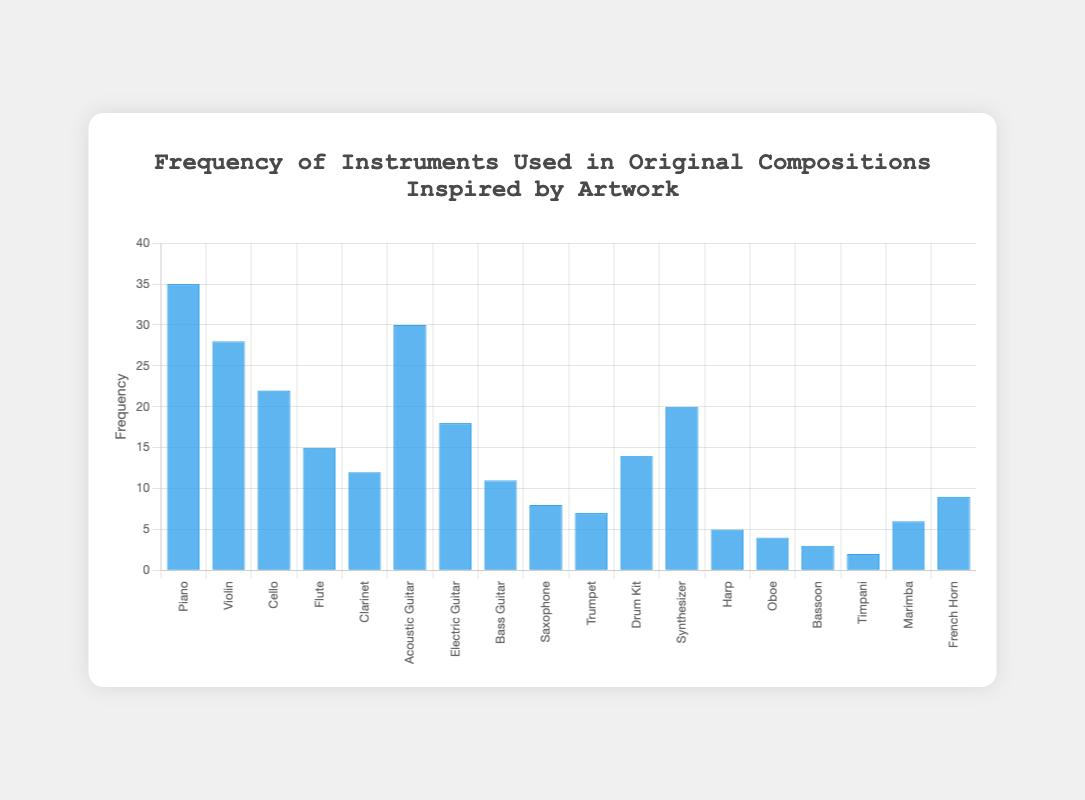Which instrument has the highest frequency on the chart? The highest bar represents the "Piano" instrument, which has a frequency of 35.
Answer: Piano Which instrument has the lowest frequency? The lowest bar represents the "Timpani" instrument, which has a frequency of 2.
Answer: Timpani How many instruments have a frequency greater than 20? By counting the bars with heights above 20: Piano (35), Violin (28), Cello (22), and Acoustic Guitar (30), there are 4 instruments.
Answer: 4 What is the combined frequency of the "Piano" and "Acoustic Guitar"? The frequencies for the Piano and Acoustic Guitar are 35 and 30 respectively. Adding them gives 35 + 30 = 65.
Answer: 65 What is the difference in frequency between the "Flute" and "Drum Kit"? The frequencies of the Flute and Drum Kit are 15 and 14 respectively. The difference is 15 - 14 = 1.
Answer: 1 Which instrument has a frequency of 20? The bar representing "Synthesizer" reaches up to 20 on the frequency scale.
Answer: Synthesizer Are there more string instruments or wind instruments in the chart? String instruments (Piano, Violin, Cello, Acoustic Guitar, Electric Guitar, Bass Guitar, Harp) total 7; Wind instruments (Flute, Clarinet, Saxophone, Trumpet, Oboe, Bassoon, French Horn) total 7. The counts are equal.
Answer: Equal Which instrument has the second highest frequency? The second highest frequency is the "Acoustic Guitar" with a frequency of 30.
Answer: Acoustic Guitar What is the total frequency of all instruments combined? Summing all individual frequencies: 35 + 28 + 22 + 15 + 12 + 30 + 18 + 11 + 8 + 7 + 14 + 20 + 5 + 4 + 3 + 2 + 6 + 9 = 249.
Answer: 249 How many instruments have a frequency between 5 and 10 (inclusive)? By checking the bars: Saxophone (8), Trumpet (7), Harp (5), Marimba (6), French Horn (9). This counts to 5 instruments.
Answer: 5 